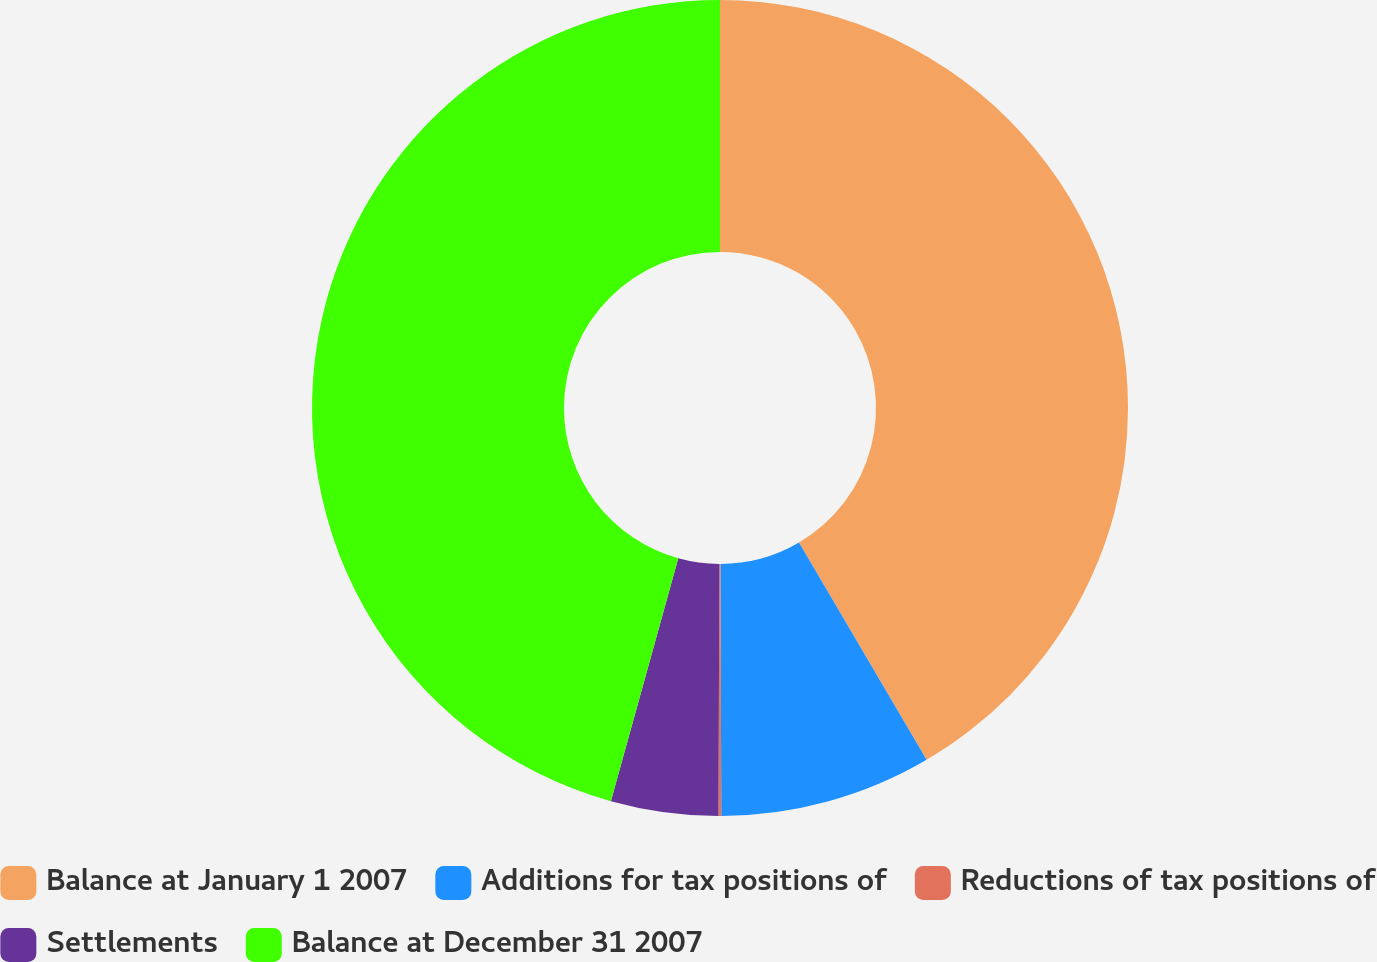Convert chart to OTSL. <chart><loc_0><loc_0><loc_500><loc_500><pie_chart><fcel>Balance at January 1 2007<fcel>Additions for tax positions of<fcel>Reductions of tax positions of<fcel>Settlements<fcel>Balance at December 31 2007<nl><fcel>41.55%<fcel>8.4%<fcel>0.11%<fcel>4.25%<fcel>45.69%<nl></chart> 